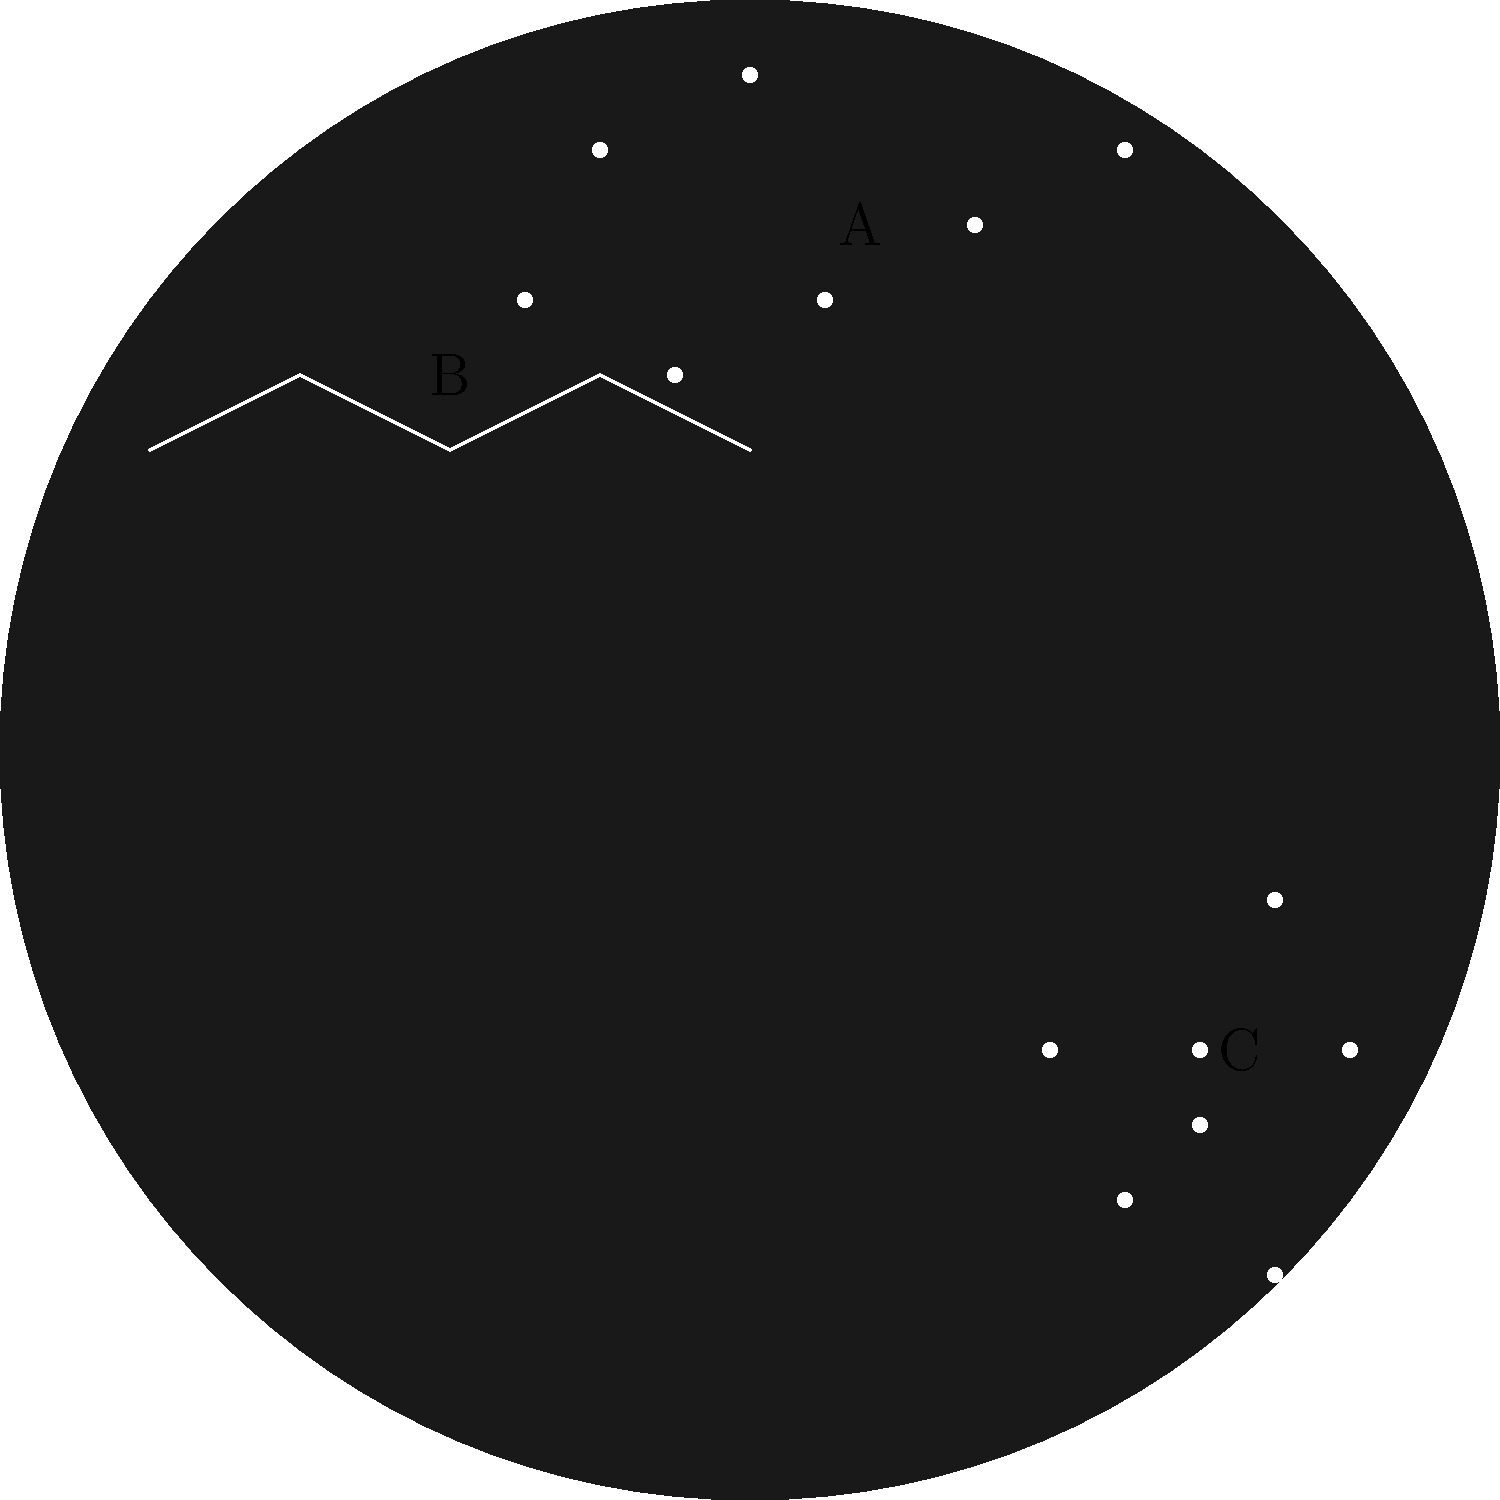In the star chart above, three constellations are marked as A, B, and C. Which of these represents Cassiopeia, known for its distinctive W or M shape? To identify Cassiopeia in this star chart, let's analyze each labeled constellation:

1. Constellation A: This appears to be a group of seven stars forming a shape similar to a dipper or a plough. This is likely Ursa Major (The Great Bear), which contains the Big Dipper asterism.

2. Constellation B: This shows five stars connected in a W or M shape. This distinctive pattern is characteristic of Cassiopeia, which is known for its easily recognizable zigzag or W/M shape.

3. Constellation C: This constellation shows a group of stars with a distinctive pattern that includes three stars in a row (often called Orion's Belt) and four bright stars forming a rough rectangle around them. This is likely Orion.

Given the distinctive W/M shape of constellation B, we can confidently identify it as Cassiopeia.
Answer: B 